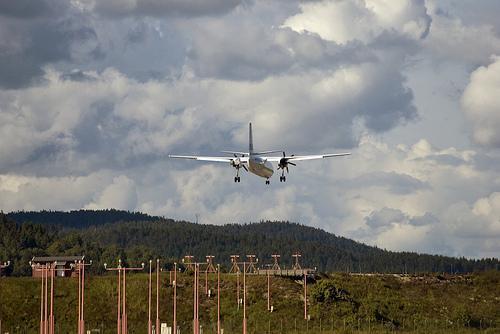How many buildings are shown?
Give a very brief answer. 1. 